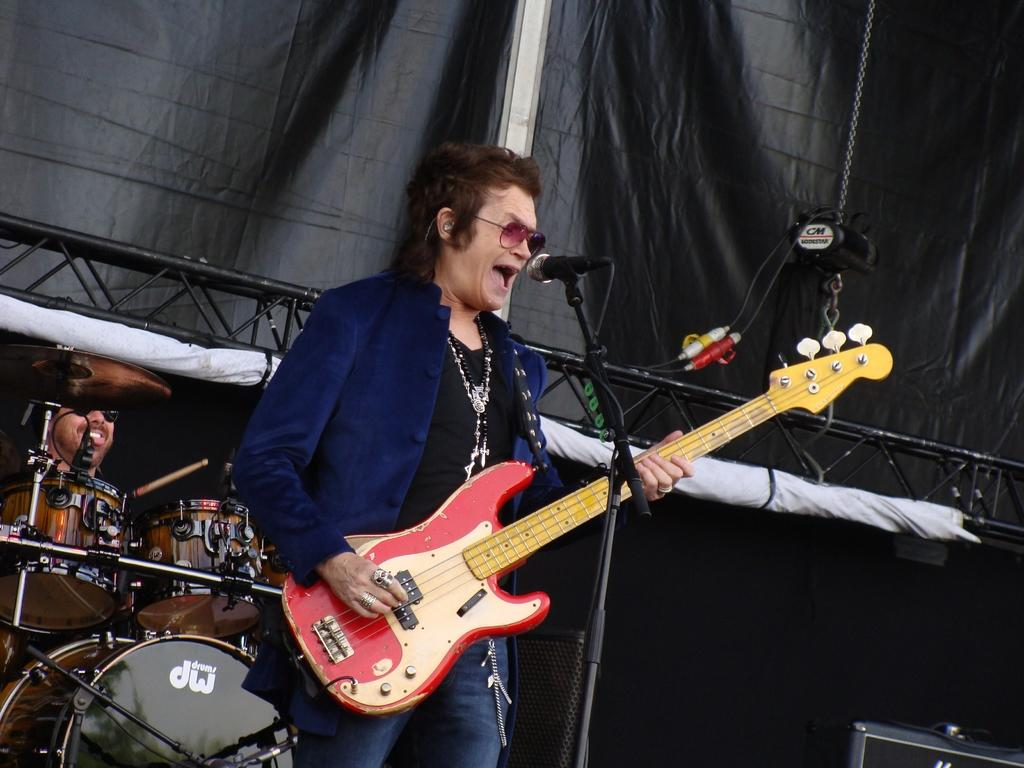What is the man in the image holding? The man is holding a guitar in the image. What is in front of the man? There is a microphone in front of the man. What can be seen in the background of the image? There are musical instruments and a sheet in the background of the image. What type of business is being conducted in the image? There is no indication of a business being conducted in the image; it appears to be a musical setting. 